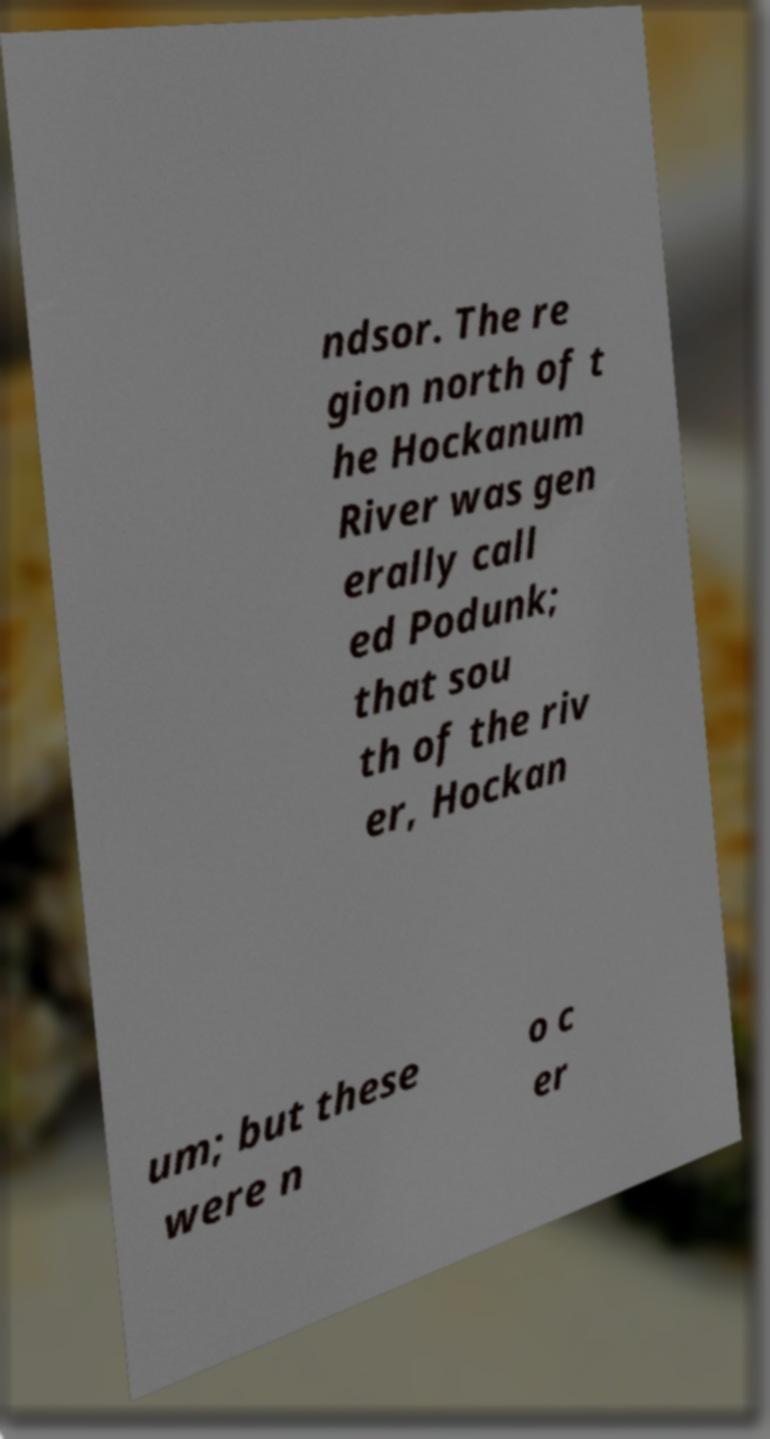Can you accurately transcribe the text from the provided image for me? ndsor. The re gion north of t he Hockanum River was gen erally call ed Podunk; that sou th of the riv er, Hockan um; but these were n o c er 